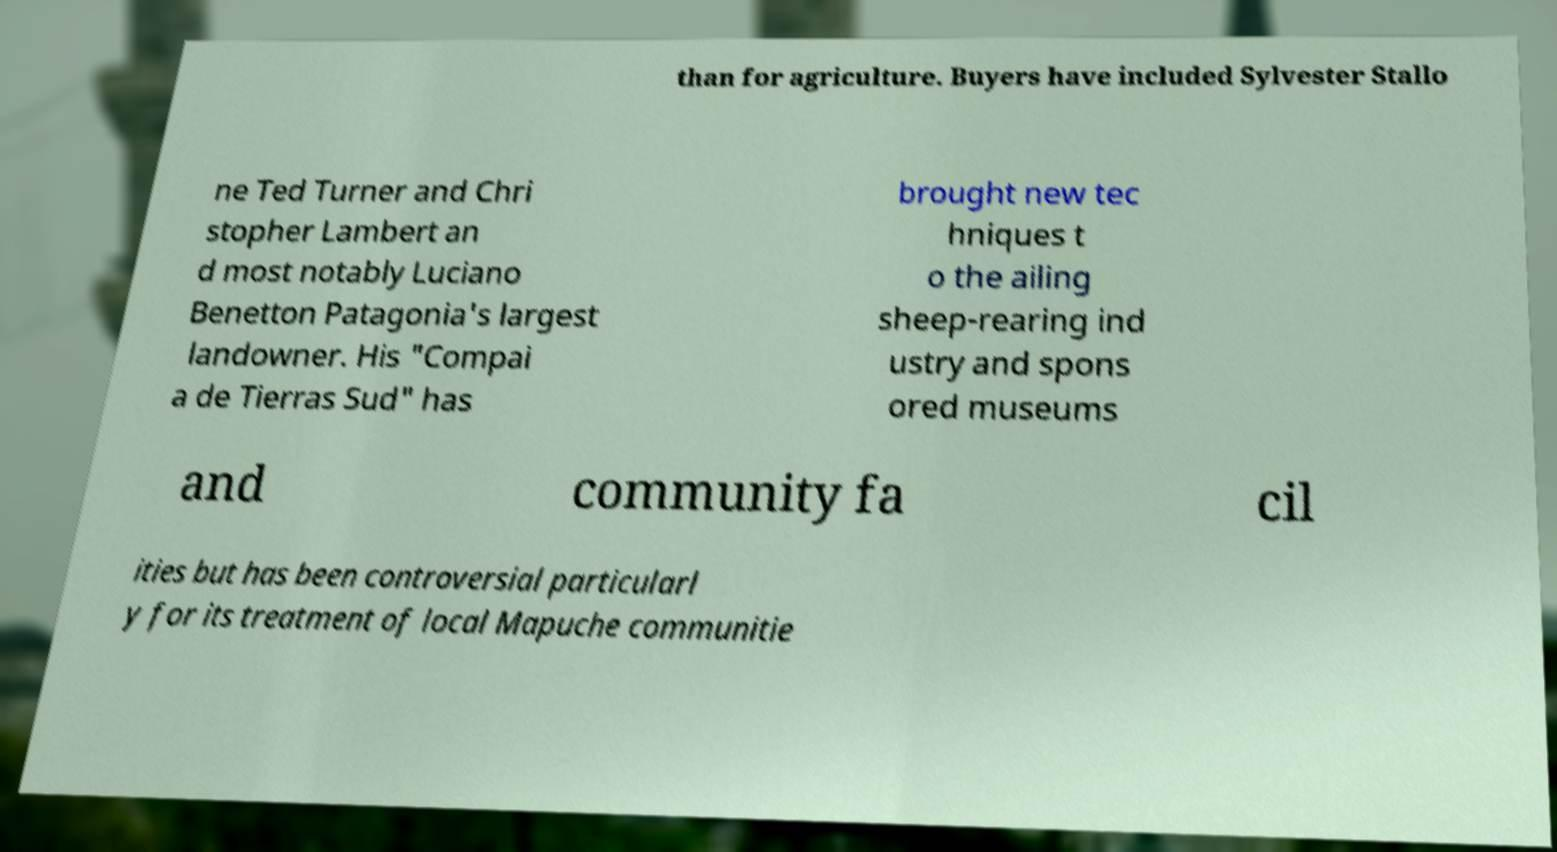Can you read and provide the text displayed in the image?This photo seems to have some interesting text. Can you extract and type it out for me? than for agriculture. Buyers have included Sylvester Stallo ne Ted Turner and Chri stopher Lambert an d most notably Luciano Benetton Patagonia's largest landowner. His "Compai a de Tierras Sud" has brought new tec hniques t o the ailing sheep-rearing ind ustry and spons ored museums and community fa cil ities but has been controversial particularl y for its treatment of local Mapuche communitie 